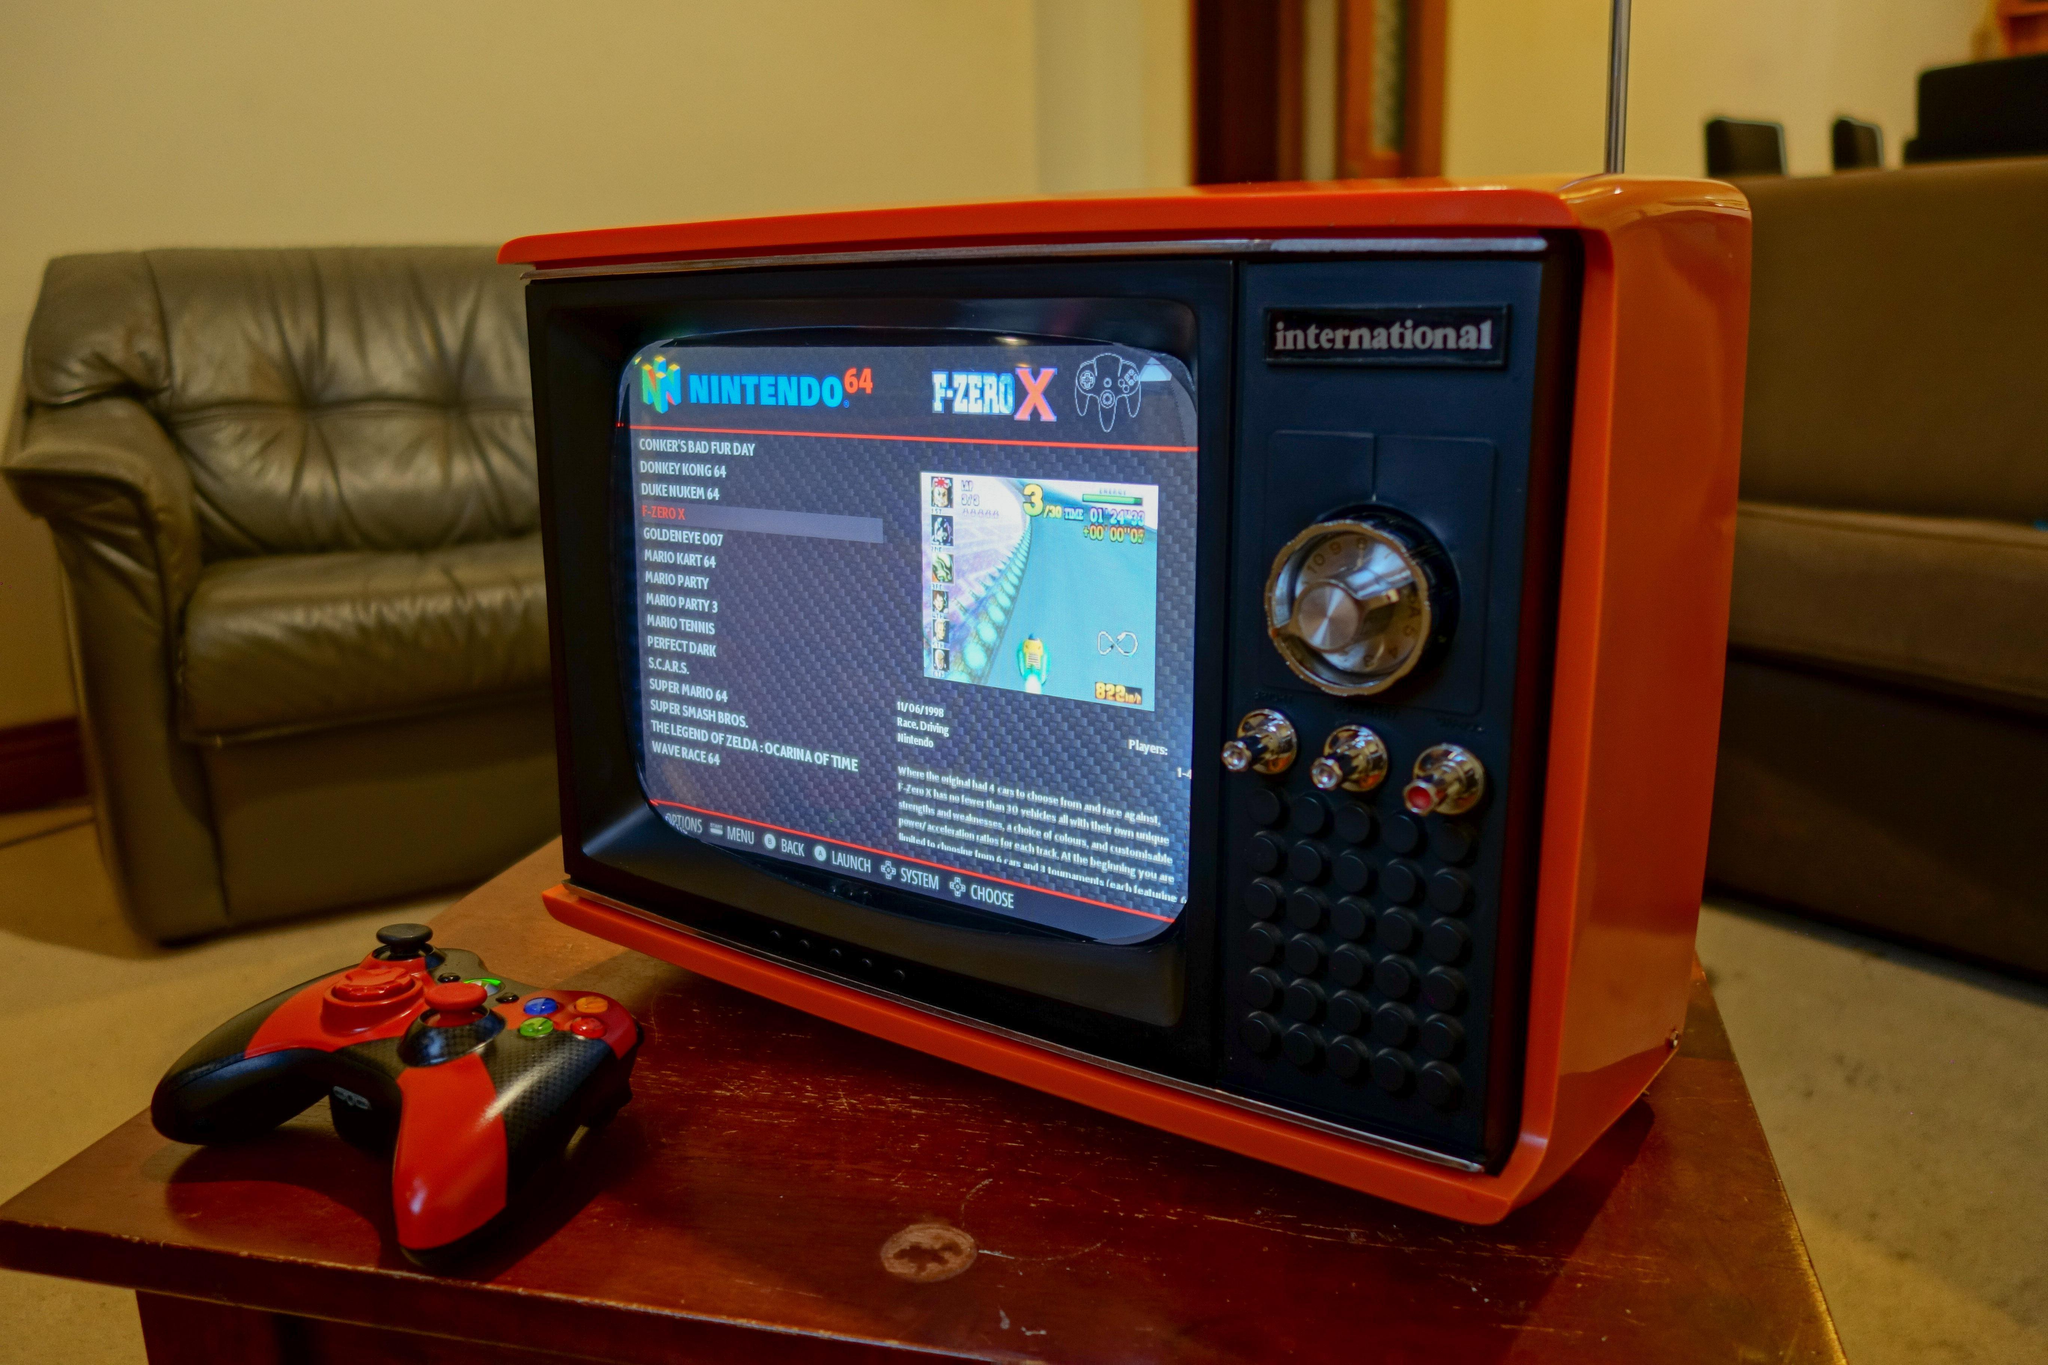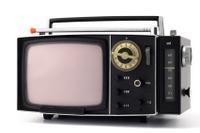The first image is the image on the left, the second image is the image on the right. Assess this claim about the two images: "One TV has a handle projecting from the top, and the other TV has an orange case and sits on a table by a game controller.". Correct or not? Answer yes or no. Yes. The first image is the image on the left, the second image is the image on the right. For the images displayed, is the sentence "One of the images shows a video game controller near a television." factually correct? Answer yes or no. Yes. 